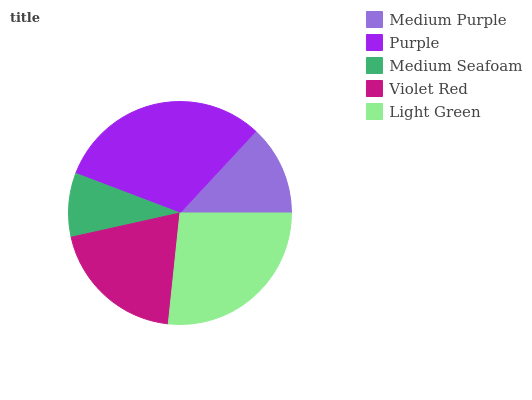Is Medium Seafoam the minimum?
Answer yes or no. Yes. Is Purple the maximum?
Answer yes or no. Yes. Is Purple the minimum?
Answer yes or no. No. Is Medium Seafoam the maximum?
Answer yes or no. No. Is Purple greater than Medium Seafoam?
Answer yes or no. Yes. Is Medium Seafoam less than Purple?
Answer yes or no. Yes. Is Medium Seafoam greater than Purple?
Answer yes or no. No. Is Purple less than Medium Seafoam?
Answer yes or no. No. Is Violet Red the high median?
Answer yes or no. Yes. Is Violet Red the low median?
Answer yes or no. Yes. Is Medium Purple the high median?
Answer yes or no. No. Is Purple the low median?
Answer yes or no. No. 